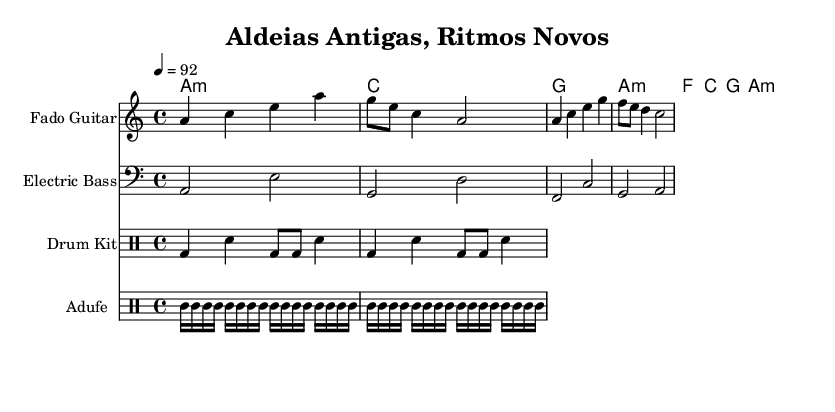What is the key signature of this music? The key signature is indicated at the beginning of the staff with the key of A minor, which is the relative minor of C major and has no sharps or flats.
Answer: A minor What is the time signature of the piece? The time signature is shown at the beginning of the staff with "4/4," which means there are four beats per measure and a quarter note gets one beat.
Answer: 4/4 What is the tempo marking? The tempo marking is found at the beginning of the score, showing that the piece should be played at a speed of 92 beats per minute, specified as "4 = 92."
Answer: 92 How many instruments are featured in this score? The score consists of four different staves for instruments: Fado Guitar, Electric Bass, Drum Kit, and Adufe, indicating four distinct instruments in the arrangement.
Answer: Four Which instrument plays in a minor key? The Fado Guitar plays a sequence of notes that are primarily centered around the A minor chord, showcasing the minor key characteristic of the piece.
Answer: Fado Guitar What type of percussion is represented by "tt"? The "tt" notation appears in the Adufe part of the score, indicating the sound of the Adufe, a traditional Portuguese frame drum, providing a folk rhythmic element to the hip-hop fusion.
Answer: Adufe 